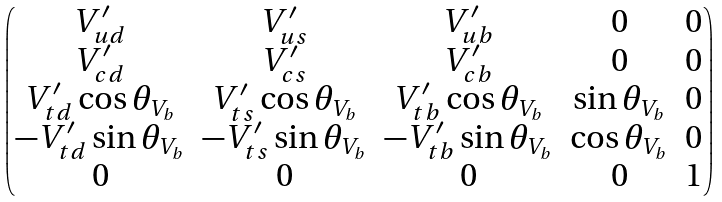Convert formula to latex. <formula><loc_0><loc_0><loc_500><loc_500>\begin{pmatrix} V ^ { \prime } _ { u d } & V ^ { \prime } _ { u s } & V ^ { \prime } _ { u b } & 0 & 0 \\ V ^ { \prime } _ { c d } & V ^ { \prime } _ { c s } & V ^ { \prime } _ { c b } & 0 & 0 \\ V ^ { \prime } _ { t d } \cos \theta _ { V _ { b } } & V ^ { \prime } _ { t s } \cos \theta _ { V _ { b } } & V ^ { \prime } _ { t b } \cos \theta _ { V _ { b } } & \sin \theta _ { V _ { b } } & 0 \\ - V ^ { \prime } _ { t d } \sin \theta _ { V _ { b } } & - V ^ { \prime } _ { t s } \sin \theta _ { V _ { b } } & - V ^ { \prime } _ { t b } \sin \theta _ { V _ { b } } & \cos \theta _ { V _ { b } } & 0 \\ 0 & 0 & 0 & 0 & 1 \end{pmatrix}</formula> 